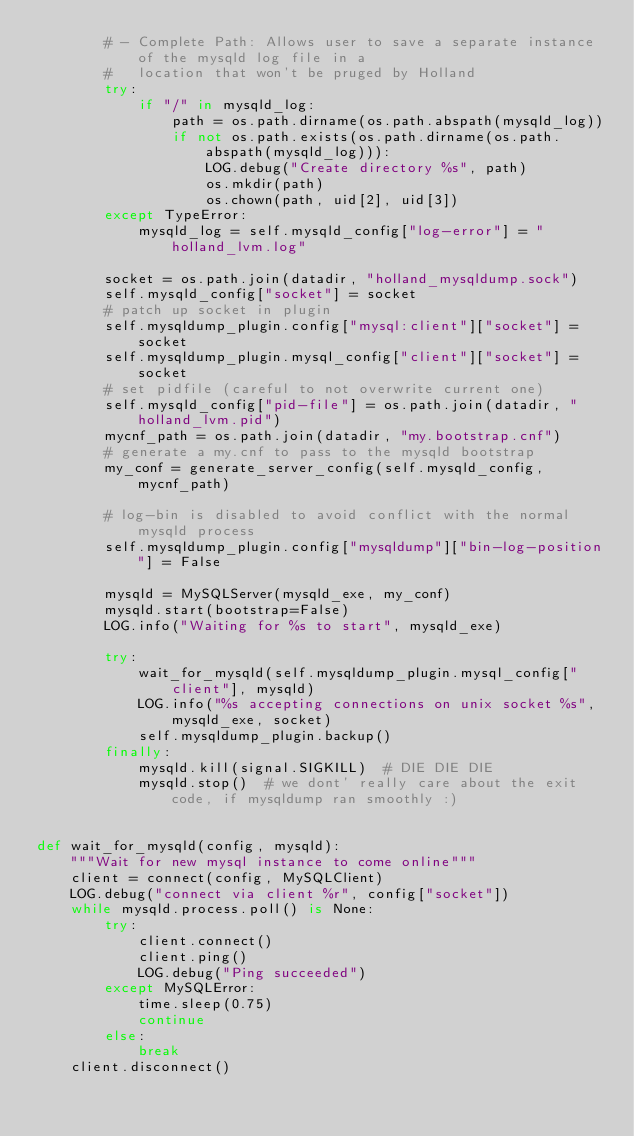Convert code to text. <code><loc_0><loc_0><loc_500><loc_500><_Python_>        # - Complete Path: Allows user to save a separate instance of the mysqld log file in a
        #   location that won't be pruged by Holland
        try:
            if "/" in mysqld_log:
                path = os.path.dirname(os.path.abspath(mysqld_log))
                if not os.path.exists(os.path.dirname(os.path.abspath(mysqld_log))):
                    LOG.debug("Create directory %s", path)
                    os.mkdir(path)
                    os.chown(path, uid[2], uid[3])
        except TypeError:
            mysqld_log = self.mysqld_config["log-error"] = "holland_lvm.log"

        socket = os.path.join(datadir, "holland_mysqldump.sock")
        self.mysqld_config["socket"] = socket
        # patch up socket in plugin
        self.mysqldump_plugin.config["mysql:client"]["socket"] = socket
        self.mysqldump_plugin.mysql_config["client"]["socket"] = socket
        # set pidfile (careful to not overwrite current one)
        self.mysqld_config["pid-file"] = os.path.join(datadir, "holland_lvm.pid")
        mycnf_path = os.path.join(datadir, "my.bootstrap.cnf")
        # generate a my.cnf to pass to the mysqld bootstrap
        my_conf = generate_server_config(self.mysqld_config, mycnf_path)

        # log-bin is disabled to avoid conflict with the normal mysqld process
        self.mysqldump_plugin.config["mysqldump"]["bin-log-position"] = False

        mysqld = MySQLServer(mysqld_exe, my_conf)
        mysqld.start(bootstrap=False)
        LOG.info("Waiting for %s to start", mysqld_exe)

        try:
            wait_for_mysqld(self.mysqldump_plugin.mysql_config["client"], mysqld)
            LOG.info("%s accepting connections on unix socket %s", mysqld_exe, socket)
            self.mysqldump_plugin.backup()
        finally:
            mysqld.kill(signal.SIGKILL)  # DIE DIE DIE
            mysqld.stop()  # we dont' really care about the exit code, if mysqldump ran smoothly :)


def wait_for_mysqld(config, mysqld):
    """Wait for new mysql instance to come online"""
    client = connect(config, MySQLClient)
    LOG.debug("connect via client %r", config["socket"])
    while mysqld.process.poll() is None:
        try:
            client.connect()
            client.ping()
            LOG.debug("Ping succeeded")
        except MySQLError:
            time.sleep(0.75)
            continue
        else:
            break
    client.disconnect()
</code> 